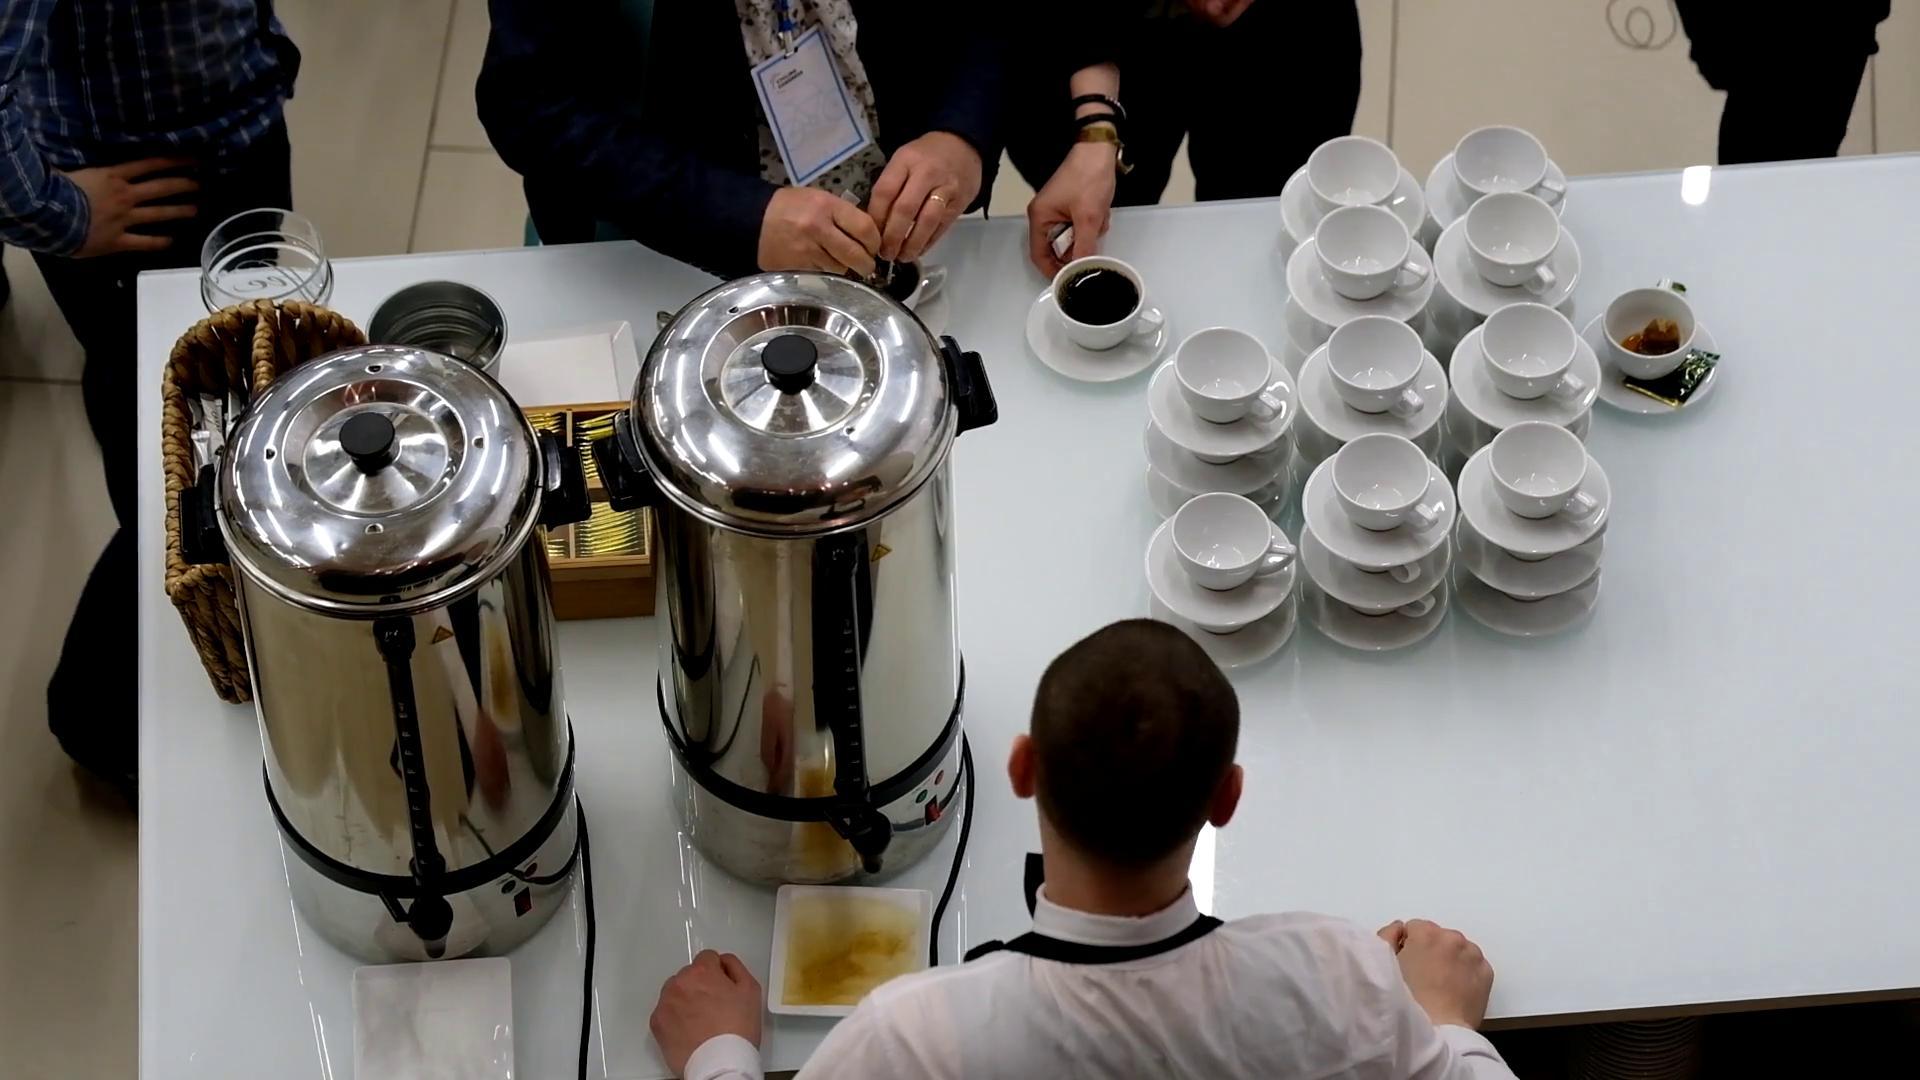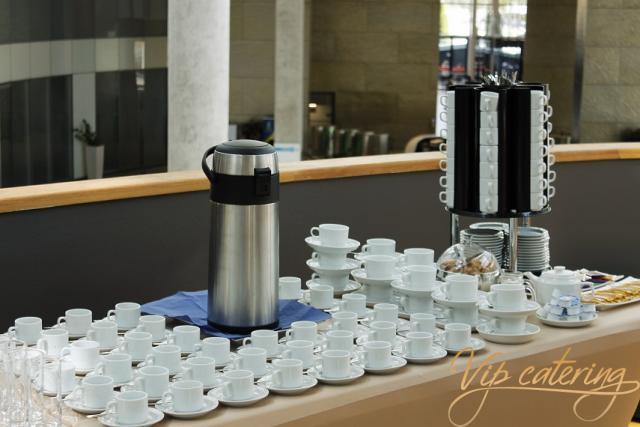The first image is the image on the left, the second image is the image on the right. Considering the images on both sides, is "At least one of the cups contains a beverage." valid? Answer yes or no. Yes. 